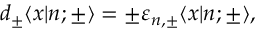<formula> <loc_0><loc_0><loc_500><loc_500>d _ { \pm } \langle x | n ; { \pm } \rangle = \pm \varepsilon _ { n , { \pm } } \langle x | n ; { \pm } \rangle ,</formula> 